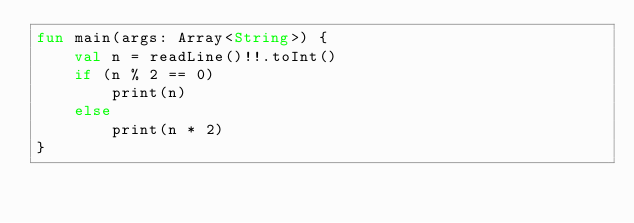Convert code to text. <code><loc_0><loc_0><loc_500><loc_500><_Kotlin_>fun main(args: Array<String>) {
    val n = readLine()!!.toInt()
    if (n % 2 == 0)
        print(n)
    else
        print(n * 2)
}</code> 